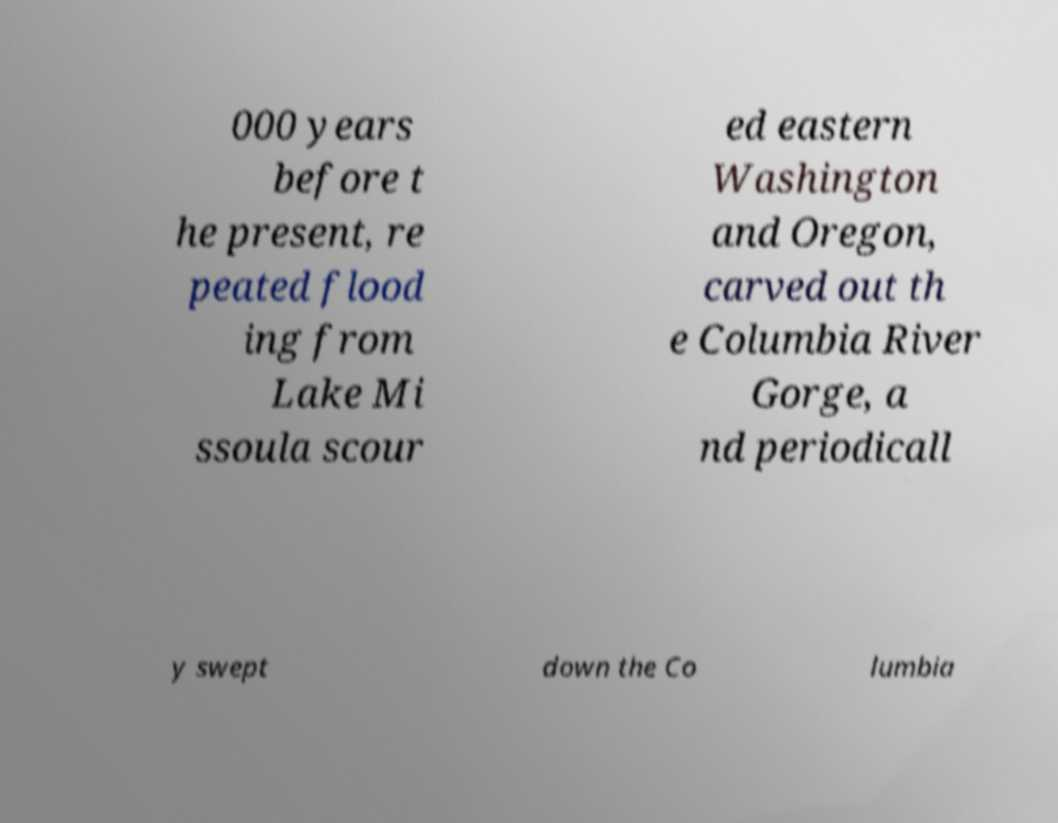For documentation purposes, I need the text within this image transcribed. Could you provide that? 000 years before t he present, re peated flood ing from Lake Mi ssoula scour ed eastern Washington and Oregon, carved out th e Columbia River Gorge, a nd periodicall y swept down the Co lumbia 